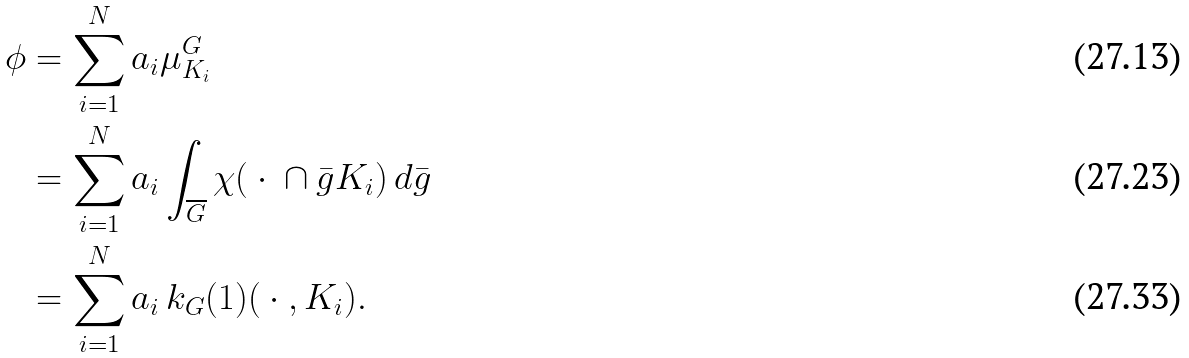Convert formula to latex. <formula><loc_0><loc_0><loc_500><loc_500>\phi & = \sum _ { i = 1 } ^ { N } a _ { i } \mu ^ { G } _ { K _ { i } } \\ & = \sum _ { i = 1 } ^ { N } a _ { i } \int _ { \overline { G } } \chi ( \ \cdot \ \cap \bar { g } K _ { i } ) \, d \bar { g } \\ & = \sum _ { i = 1 } ^ { N } a _ { i } \, k _ { G } ( 1 ) ( \ \cdot \ , K _ { i } ) .</formula> 